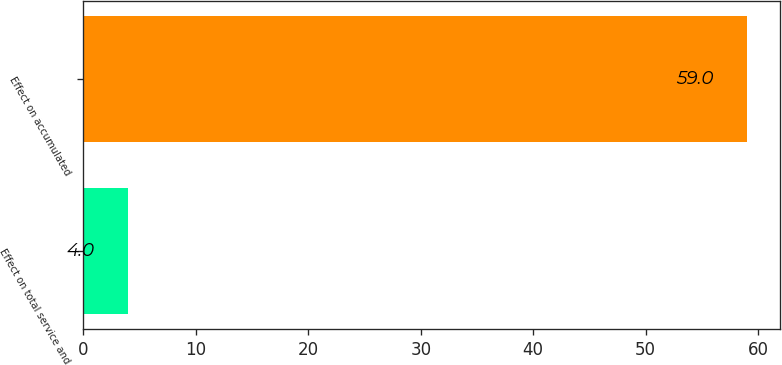Convert chart. <chart><loc_0><loc_0><loc_500><loc_500><bar_chart><fcel>Effect on total service and<fcel>Effect on accumulated<nl><fcel>4<fcel>59<nl></chart> 